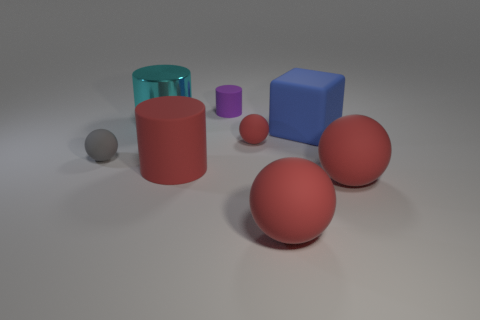Are there any other things that have the same color as the large metal cylinder?
Provide a succinct answer. No. Is the number of purple rubber things greater than the number of matte balls?
Provide a short and direct response. No. Does the cyan object have the same material as the large blue cube?
Your answer should be very brief. No. What number of other things have the same material as the tiny red object?
Your answer should be very brief. 6. There is a cyan object; is it the same size as the rubber thing to the left of the cyan shiny thing?
Offer a terse response. No. There is a cylinder that is both behind the large red cylinder and on the right side of the large cyan shiny object; what color is it?
Offer a very short reply. Purple. Is there a matte cylinder that is on the left side of the tiny gray thing in front of the cyan cylinder?
Your response must be concise. No. Is the number of big spheres to the right of the gray matte sphere the same as the number of red matte objects?
Make the answer very short. No. How many balls are in front of the tiny rubber object behind the red rubber thing that is behind the gray matte sphere?
Your answer should be very brief. 4. Is there a ball that has the same size as the red rubber cylinder?
Provide a succinct answer. Yes. 